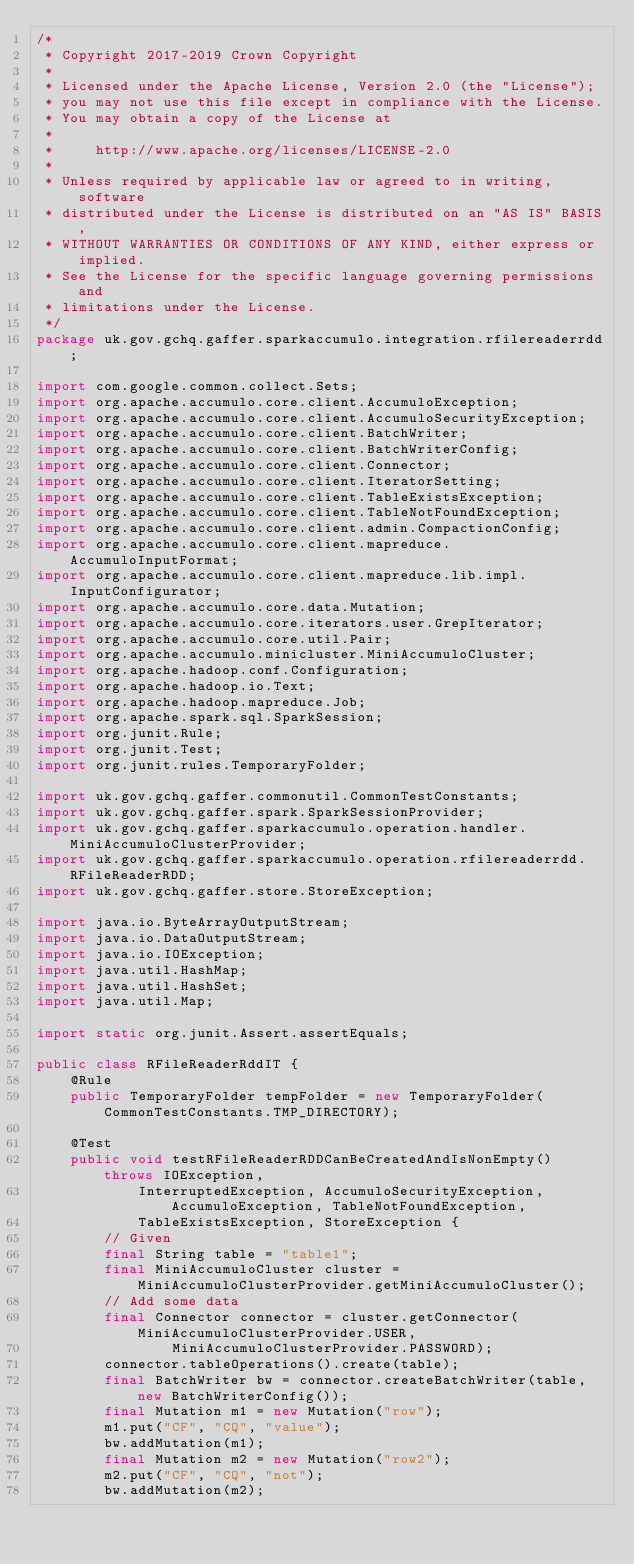<code> <loc_0><loc_0><loc_500><loc_500><_Java_>/*
 * Copyright 2017-2019 Crown Copyright
 *
 * Licensed under the Apache License, Version 2.0 (the "License");
 * you may not use this file except in compliance with the License.
 * You may obtain a copy of the License at
 *
 *     http://www.apache.org/licenses/LICENSE-2.0
 *
 * Unless required by applicable law or agreed to in writing, software
 * distributed under the License is distributed on an "AS IS" BASIS,
 * WITHOUT WARRANTIES OR CONDITIONS OF ANY KIND, either express or implied.
 * See the License for the specific language governing permissions and
 * limitations under the License.
 */
package uk.gov.gchq.gaffer.sparkaccumulo.integration.rfilereaderrdd;

import com.google.common.collect.Sets;
import org.apache.accumulo.core.client.AccumuloException;
import org.apache.accumulo.core.client.AccumuloSecurityException;
import org.apache.accumulo.core.client.BatchWriter;
import org.apache.accumulo.core.client.BatchWriterConfig;
import org.apache.accumulo.core.client.Connector;
import org.apache.accumulo.core.client.IteratorSetting;
import org.apache.accumulo.core.client.TableExistsException;
import org.apache.accumulo.core.client.TableNotFoundException;
import org.apache.accumulo.core.client.admin.CompactionConfig;
import org.apache.accumulo.core.client.mapreduce.AccumuloInputFormat;
import org.apache.accumulo.core.client.mapreduce.lib.impl.InputConfigurator;
import org.apache.accumulo.core.data.Mutation;
import org.apache.accumulo.core.iterators.user.GrepIterator;
import org.apache.accumulo.core.util.Pair;
import org.apache.accumulo.minicluster.MiniAccumuloCluster;
import org.apache.hadoop.conf.Configuration;
import org.apache.hadoop.io.Text;
import org.apache.hadoop.mapreduce.Job;
import org.apache.spark.sql.SparkSession;
import org.junit.Rule;
import org.junit.Test;
import org.junit.rules.TemporaryFolder;

import uk.gov.gchq.gaffer.commonutil.CommonTestConstants;
import uk.gov.gchq.gaffer.spark.SparkSessionProvider;
import uk.gov.gchq.gaffer.sparkaccumulo.operation.handler.MiniAccumuloClusterProvider;
import uk.gov.gchq.gaffer.sparkaccumulo.operation.rfilereaderrdd.RFileReaderRDD;
import uk.gov.gchq.gaffer.store.StoreException;

import java.io.ByteArrayOutputStream;
import java.io.DataOutputStream;
import java.io.IOException;
import java.util.HashMap;
import java.util.HashSet;
import java.util.Map;

import static org.junit.Assert.assertEquals;

public class RFileReaderRddIT {
    @Rule
    public TemporaryFolder tempFolder = new TemporaryFolder(CommonTestConstants.TMP_DIRECTORY);

    @Test
    public void testRFileReaderRDDCanBeCreatedAndIsNonEmpty() throws IOException,
            InterruptedException, AccumuloSecurityException, AccumuloException, TableNotFoundException,
            TableExistsException, StoreException {
        // Given
        final String table = "table1";
        final MiniAccumuloCluster cluster = MiniAccumuloClusterProvider.getMiniAccumuloCluster();
        // Add some data
        final Connector connector = cluster.getConnector(MiniAccumuloClusterProvider.USER,
                MiniAccumuloClusterProvider.PASSWORD);
        connector.tableOperations().create(table);
        final BatchWriter bw = connector.createBatchWriter(table, new BatchWriterConfig());
        final Mutation m1 = new Mutation("row");
        m1.put("CF", "CQ", "value");
        bw.addMutation(m1);
        final Mutation m2 = new Mutation("row2");
        m2.put("CF", "CQ", "not");
        bw.addMutation(m2);</code> 